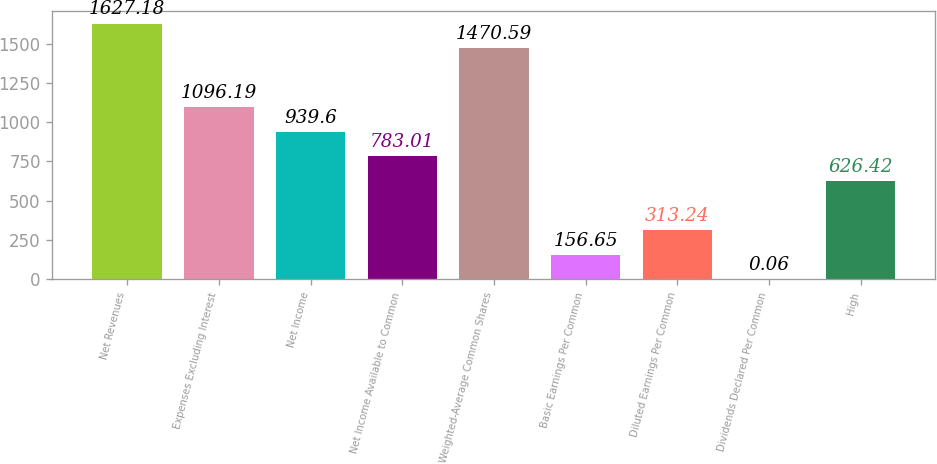<chart> <loc_0><loc_0><loc_500><loc_500><bar_chart><fcel>Net Revenues<fcel>Expenses Excluding Interest<fcel>Net Income<fcel>Net Income Available to Common<fcel>Weighted-Average Common Shares<fcel>Basic Earnings Per Common<fcel>Diluted Earnings Per Common<fcel>Dividends Declared Per Common<fcel>High<nl><fcel>1627.18<fcel>1096.19<fcel>939.6<fcel>783.01<fcel>1470.59<fcel>156.65<fcel>313.24<fcel>0.06<fcel>626.42<nl></chart> 